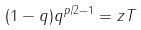Convert formula to latex. <formula><loc_0><loc_0><loc_500><loc_500>( 1 - q ) q ^ { p / 2 - 1 } = z T</formula> 